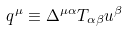<formula> <loc_0><loc_0><loc_500><loc_500>q ^ { \mu } \equiv \Delta ^ { \mu \alpha } T _ { \alpha \beta } u ^ { \beta }</formula> 